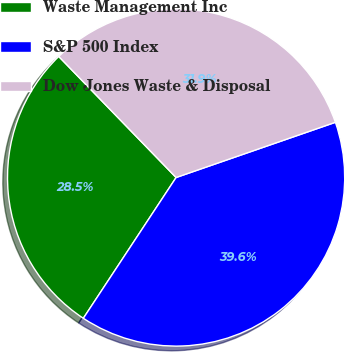<chart> <loc_0><loc_0><loc_500><loc_500><pie_chart><fcel>Waste Management Inc<fcel>S&P 500 Index<fcel>Dow Jones Waste & Disposal<nl><fcel>28.47%<fcel>39.58%<fcel>31.94%<nl></chart> 